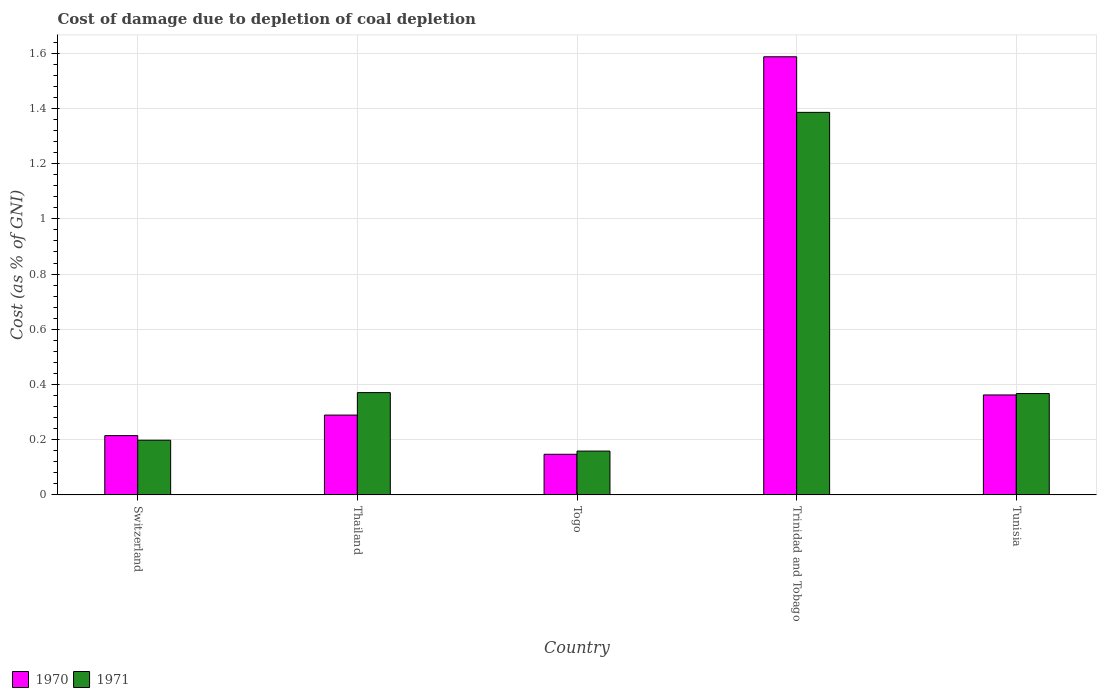How many groups of bars are there?
Offer a very short reply. 5. Are the number of bars on each tick of the X-axis equal?
Provide a succinct answer. Yes. How many bars are there on the 5th tick from the right?
Keep it short and to the point. 2. What is the label of the 1st group of bars from the left?
Keep it short and to the point. Switzerland. What is the cost of damage caused due to coal depletion in 1971 in Thailand?
Your response must be concise. 0.37. Across all countries, what is the maximum cost of damage caused due to coal depletion in 1970?
Keep it short and to the point. 1.59. Across all countries, what is the minimum cost of damage caused due to coal depletion in 1971?
Offer a very short reply. 0.16. In which country was the cost of damage caused due to coal depletion in 1971 maximum?
Your answer should be very brief. Trinidad and Tobago. In which country was the cost of damage caused due to coal depletion in 1970 minimum?
Your response must be concise. Togo. What is the total cost of damage caused due to coal depletion in 1970 in the graph?
Offer a terse response. 2.6. What is the difference between the cost of damage caused due to coal depletion in 1971 in Thailand and that in Togo?
Offer a very short reply. 0.21. What is the difference between the cost of damage caused due to coal depletion in 1970 in Togo and the cost of damage caused due to coal depletion in 1971 in Tunisia?
Make the answer very short. -0.22. What is the average cost of damage caused due to coal depletion in 1971 per country?
Give a very brief answer. 0.5. What is the difference between the cost of damage caused due to coal depletion of/in 1970 and cost of damage caused due to coal depletion of/in 1971 in Trinidad and Tobago?
Provide a short and direct response. 0.2. In how many countries, is the cost of damage caused due to coal depletion in 1971 greater than 1.08 %?
Give a very brief answer. 1. What is the ratio of the cost of damage caused due to coal depletion in 1971 in Switzerland to that in Togo?
Your answer should be compact. 1.25. Is the difference between the cost of damage caused due to coal depletion in 1970 in Thailand and Trinidad and Tobago greater than the difference between the cost of damage caused due to coal depletion in 1971 in Thailand and Trinidad and Tobago?
Provide a succinct answer. No. What is the difference between the highest and the second highest cost of damage caused due to coal depletion in 1970?
Make the answer very short. -1.23. What is the difference between the highest and the lowest cost of damage caused due to coal depletion in 1971?
Ensure brevity in your answer.  1.23. How many bars are there?
Give a very brief answer. 10. What is the difference between two consecutive major ticks on the Y-axis?
Make the answer very short. 0.2. Are the values on the major ticks of Y-axis written in scientific E-notation?
Your response must be concise. No. Does the graph contain grids?
Give a very brief answer. Yes. How are the legend labels stacked?
Make the answer very short. Horizontal. What is the title of the graph?
Offer a terse response. Cost of damage due to depletion of coal depletion. What is the label or title of the X-axis?
Provide a short and direct response. Country. What is the label or title of the Y-axis?
Make the answer very short. Cost (as % of GNI). What is the Cost (as % of GNI) of 1970 in Switzerland?
Keep it short and to the point. 0.21. What is the Cost (as % of GNI) in 1971 in Switzerland?
Provide a short and direct response. 0.2. What is the Cost (as % of GNI) in 1970 in Thailand?
Ensure brevity in your answer.  0.29. What is the Cost (as % of GNI) in 1971 in Thailand?
Ensure brevity in your answer.  0.37. What is the Cost (as % of GNI) of 1970 in Togo?
Offer a very short reply. 0.15. What is the Cost (as % of GNI) in 1971 in Togo?
Make the answer very short. 0.16. What is the Cost (as % of GNI) in 1970 in Trinidad and Tobago?
Make the answer very short. 1.59. What is the Cost (as % of GNI) in 1971 in Trinidad and Tobago?
Offer a terse response. 1.39. What is the Cost (as % of GNI) in 1970 in Tunisia?
Your answer should be very brief. 0.36. What is the Cost (as % of GNI) in 1971 in Tunisia?
Provide a short and direct response. 0.37. Across all countries, what is the maximum Cost (as % of GNI) in 1970?
Provide a short and direct response. 1.59. Across all countries, what is the maximum Cost (as % of GNI) of 1971?
Your answer should be compact. 1.39. Across all countries, what is the minimum Cost (as % of GNI) in 1970?
Your response must be concise. 0.15. Across all countries, what is the minimum Cost (as % of GNI) in 1971?
Your answer should be very brief. 0.16. What is the total Cost (as % of GNI) in 1970 in the graph?
Provide a short and direct response. 2.6. What is the total Cost (as % of GNI) of 1971 in the graph?
Provide a succinct answer. 2.48. What is the difference between the Cost (as % of GNI) in 1970 in Switzerland and that in Thailand?
Ensure brevity in your answer.  -0.07. What is the difference between the Cost (as % of GNI) in 1971 in Switzerland and that in Thailand?
Provide a short and direct response. -0.17. What is the difference between the Cost (as % of GNI) in 1970 in Switzerland and that in Togo?
Provide a succinct answer. 0.07. What is the difference between the Cost (as % of GNI) of 1971 in Switzerland and that in Togo?
Your answer should be compact. 0.04. What is the difference between the Cost (as % of GNI) of 1970 in Switzerland and that in Trinidad and Tobago?
Your answer should be compact. -1.37. What is the difference between the Cost (as % of GNI) of 1971 in Switzerland and that in Trinidad and Tobago?
Ensure brevity in your answer.  -1.19. What is the difference between the Cost (as % of GNI) in 1970 in Switzerland and that in Tunisia?
Your answer should be very brief. -0.15. What is the difference between the Cost (as % of GNI) of 1971 in Switzerland and that in Tunisia?
Make the answer very short. -0.17. What is the difference between the Cost (as % of GNI) in 1970 in Thailand and that in Togo?
Offer a very short reply. 0.14. What is the difference between the Cost (as % of GNI) of 1971 in Thailand and that in Togo?
Your answer should be very brief. 0.21. What is the difference between the Cost (as % of GNI) of 1970 in Thailand and that in Trinidad and Tobago?
Provide a succinct answer. -1.3. What is the difference between the Cost (as % of GNI) in 1971 in Thailand and that in Trinidad and Tobago?
Provide a short and direct response. -1.02. What is the difference between the Cost (as % of GNI) in 1970 in Thailand and that in Tunisia?
Ensure brevity in your answer.  -0.07. What is the difference between the Cost (as % of GNI) in 1971 in Thailand and that in Tunisia?
Make the answer very short. 0. What is the difference between the Cost (as % of GNI) of 1970 in Togo and that in Trinidad and Tobago?
Offer a very short reply. -1.44. What is the difference between the Cost (as % of GNI) of 1971 in Togo and that in Trinidad and Tobago?
Keep it short and to the point. -1.23. What is the difference between the Cost (as % of GNI) of 1970 in Togo and that in Tunisia?
Keep it short and to the point. -0.21. What is the difference between the Cost (as % of GNI) of 1971 in Togo and that in Tunisia?
Offer a very short reply. -0.21. What is the difference between the Cost (as % of GNI) in 1970 in Trinidad and Tobago and that in Tunisia?
Ensure brevity in your answer.  1.23. What is the difference between the Cost (as % of GNI) in 1971 in Trinidad and Tobago and that in Tunisia?
Your answer should be compact. 1.02. What is the difference between the Cost (as % of GNI) of 1970 in Switzerland and the Cost (as % of GNI) of 1971 in Thailand?
Your answer should be compact. -0.16. What is the difference between the Cost (as % of GNI) in 1970 in Switzerland and the Cost (as % of GNI) in 1971 in Togo?
Your answer should be compact. 0.06. What is the difference between the Cost (as % of GNI) of 1970 in Switzerland and the Cost (as % of GNI) of 1971 in Trinidad and Tobago?
Give a very brief answer. -1.17. What is the difference between the Cost (as % of GNI) in 1970 in Switzerland and the Cost (as % of GNI) in 1971 in Tunisia?
Offer a very short reply. -0.15. What is the difference between the Cost (as % of GNI) in 1970 in Thailand and the Cost (as % of GNI) in 1971 in Togo?
Give a very brief answer. 0.13. What is the difference between the Cost (as % of GNI) in 1970 in Thailand and the Cost (as % of GNI) in 1971 in Trinidad and Tobago?
Provide a short and direct response. -1.1. What is the difference between the Cost (as % of GNI) in 1970 in Thailand and the Cost (as % of GNI) in 1971 in Tunisia?
Offer a very short reply. -0.08. What is the difference between the Cost (as % of GNI) in 1970 in Togo and the Cost (as % of GNI) in 1971 in Trinidad and Tobago?
Provide a short and direct response. -1.24. What is the difference between the Cost (as % of GNI) of 1970 in Togo and the Cost (as % of GNI) of 1971 in Tunisia?
Offer a terse response. -0.22. What is the difference between the Cost (as % of GNI) in 1970 in Trinidad and Tobago and the Cost (as % of GNI) in 1971 in Tunisia?
Offer a terse response. 1.22. What is the average Cost (as % of GNI) of 1970 per country?
Offer a terse response. 0.52. What is the average Cost (as % of GNI) in 1971 per country?
Your answer should be very brief. 0.5. What is the difference between the Cost (as % of GNI) of 1970 and Cost (as % of GNI) of 1971 in Switzerland?
Offer a very short reply. 0.02. What is the difference between the Cost (as % of GNI) of 1970 and Cost (as % of GNI) of 1971 in Thailand?
Provide a short and direct response. -0.08. What is the difference between the Cost (as % of GNI) in 1970 and Cost (as % of GNI) in 1971 in Togo?
Your response must be concise. -0.01. What is the difference between the Cost (as % of GNI) of 1970 and Cost (as % of GNI) of 1971 in Trinidad and Tobago?
Keep it short and to the point. 0.2. What is the difference between the Cost (as % of GNI) in 1970 and Cost (as % of GNI) in 1971 in Tunisia?
Your response must be concise. -0.01. What is the ratio of the Cost (as % of GNI) in 1970 in Switzerland to that in Thailand?
Your answer should be compact. 0.74. What is the ratio of the Cost (as % of GNI) of 1971 in Switzerland to that in Thailand?
Give a very brief answer. 0.53. What is the ratio of the Cost (as % of GNI) of 1970 in Switzerland to that in Togo?
Your answer should be very brief. 1.46. What is the ratio of the Cost (as % of GNI) in 1971 in Switzerland to that in Togo?
Offer a terse response. 1.25. What is the ratio of the Cost (as % of GNI) of 1970 in Switzerland to that in Trinidad and Tobago?
Provide a succinct answer. 0.14. What is the ratio of the Cost (as % of GNI) in 1971 in Switzerland to that in Trinidad and Tobago?
Keep it short and to the point. 0.14. What is the ratio of the Cost (as % of GNI) in 1970 in Switzerland to that in Tunisia?
Ensure brevity in your answer.  0.59. What is the ratio of the Cost (as % of GNI) of 1971 in Switzerland to that in Tunisia?
Provide a short and direct response. 0.54. What is the ratio of the Cost (as % of GNI) of 1970 in Thailand to that in Togo?
Offer a terse response. 1.97. What is the ratio of the Cost (as % of GNI) in 1971 in Thailand to that in Togo?
Provide a short and direct response. 2.33. What is the ratio of the Cost (as % of GNI) of 1970 in Thailand to that in Trinidad and Tobago?
Provide a succinct answer. 0.18. What is the ratio of the Cost (as % of GNI) of 1971 in Thailand to that in Trinidad and Tobago?
Ensure brevity in your answer.  0.27. What is the ratio of the Cost (as % of GNI) of 1970 in Thailand to that in Tunisia?
Your response must be concise. 0.8. What is the ratio of the Cost (as % of GNI) in 1971 in Thailand to that in Tunisia?
Your answer should be compact. 1.01. What is the ratio of the Cost (as % of GNI) of 1970 in Togo to that in Trinidad and Tobago?
Provide a short and direct response. 0.09. What is the ratio of the Cost (as % of GNI) in 1971 in Togo to that in Trinidad and Tobago?
Offer a very short reply. 0.11. What is the ratio of the Cost (as % of GNI) in 1970 in Togo to that in Tunisia?
Keep it short and to the point. 0.41. What is the ratio of the Cost (as % of GNI) in 1971 in Togo to that in Tunisia?
Give a very brief answer. 0.43. What is the ratio of the Cost (as % of GNI) in 1970 in Trinidad and Tobago to that in Tunisia?
Ensure brevity in your answer.  4.38. What is the ratio of the Cost (as % of GNI) in 1971 in Trinidad and Tobago to that in Tunisia?
Offer a very short reply. 3.77. What is the difference between the highest and the second highest Cost (as % of GNI) in 1970?
Your response must be concise. 1.23. What is the difference between the highest and the second highest Cost (as % of GNI) in 1971?
Ensure brevity in your answer.  1.02. What is the difference between the highest and the lowest Cost (as % of GNI) of 1970?
Your response must be concise. 1.44. What is the difference between the highest and the lowest Cost (as % of GNI) in 1971?
Ensure brevity in your answer.  1.23. 